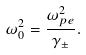<formula> <loc_0><loc_0><loc_500><loc_500>\omega _ { 0 } ^ { 2 } = \frac { \omega _ { p e } ^ { 2 } } { \gamma _ { \pm } } .</formula> 